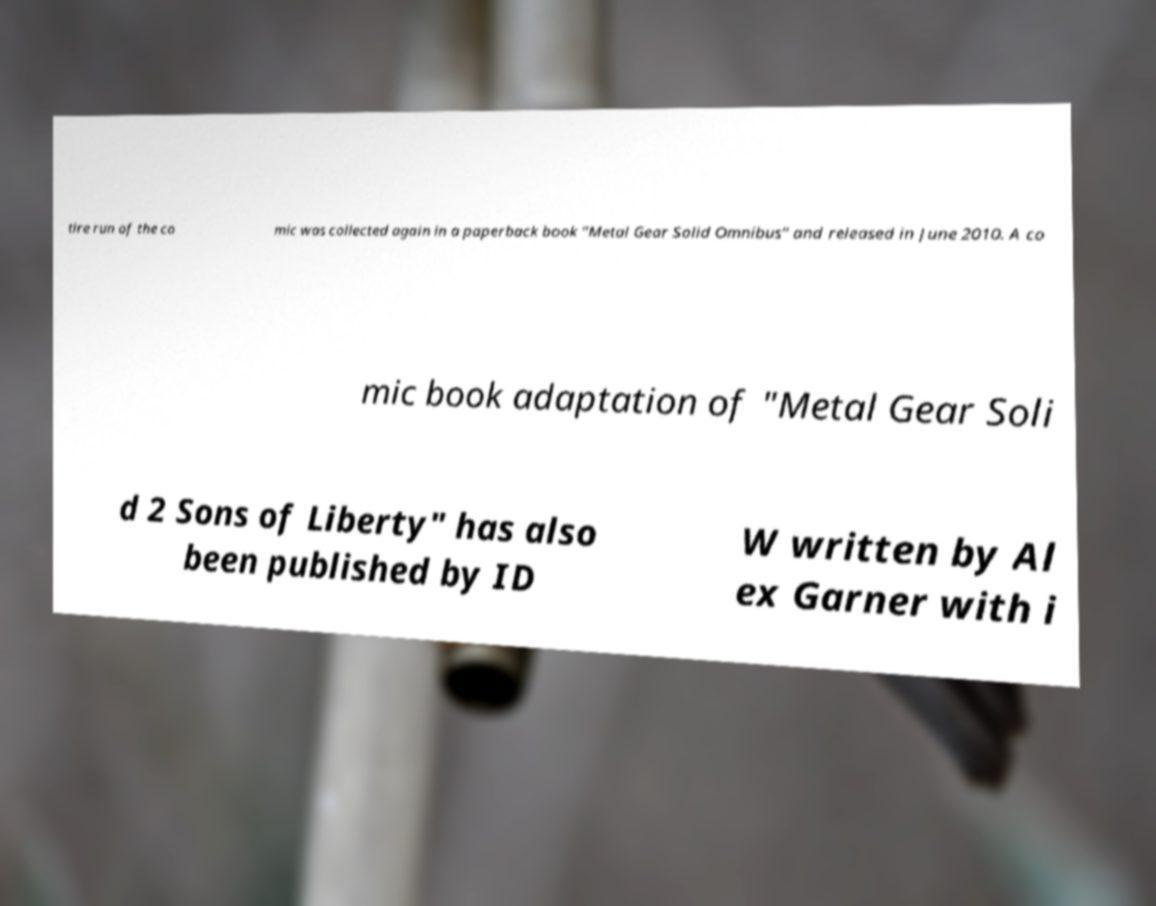Please identify and transcribe the text found in this image. tire run of the co mic was collected again in a paperback book "Metal Gear Solid Omnibus" and released in June 2010. A co mic book adaptation of "Metal Gear Soli d 2 Sons of Liberty" has also been published by ID W written by Al ex Garner with i 